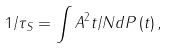<formula> <loc_0><loc_0><loc_500><loc_500>1 / \tau _ { S } = \int A ^ { 2 } t / N d P \left ( t \right ) ,</formula> 